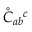Convert formula to latex. <formula><loc_0><loc_0><loc_500><loc_500>\mathring { C } _ { a b ^ { c }</formula> 